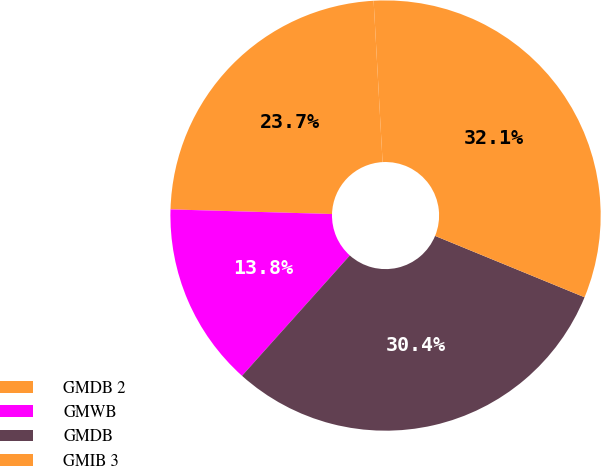Convert chart. <chart><loc_0><loc_0><loc_500><loc_500><pie_chart><fcel>GMDB 2<fcel>GMWB<fcel>GMDB<fcel>GMIB 3<nl><fcel>23.66%<fcel>13.83%<fcel>30.42%<fcel>32.08%<nl></chart> 